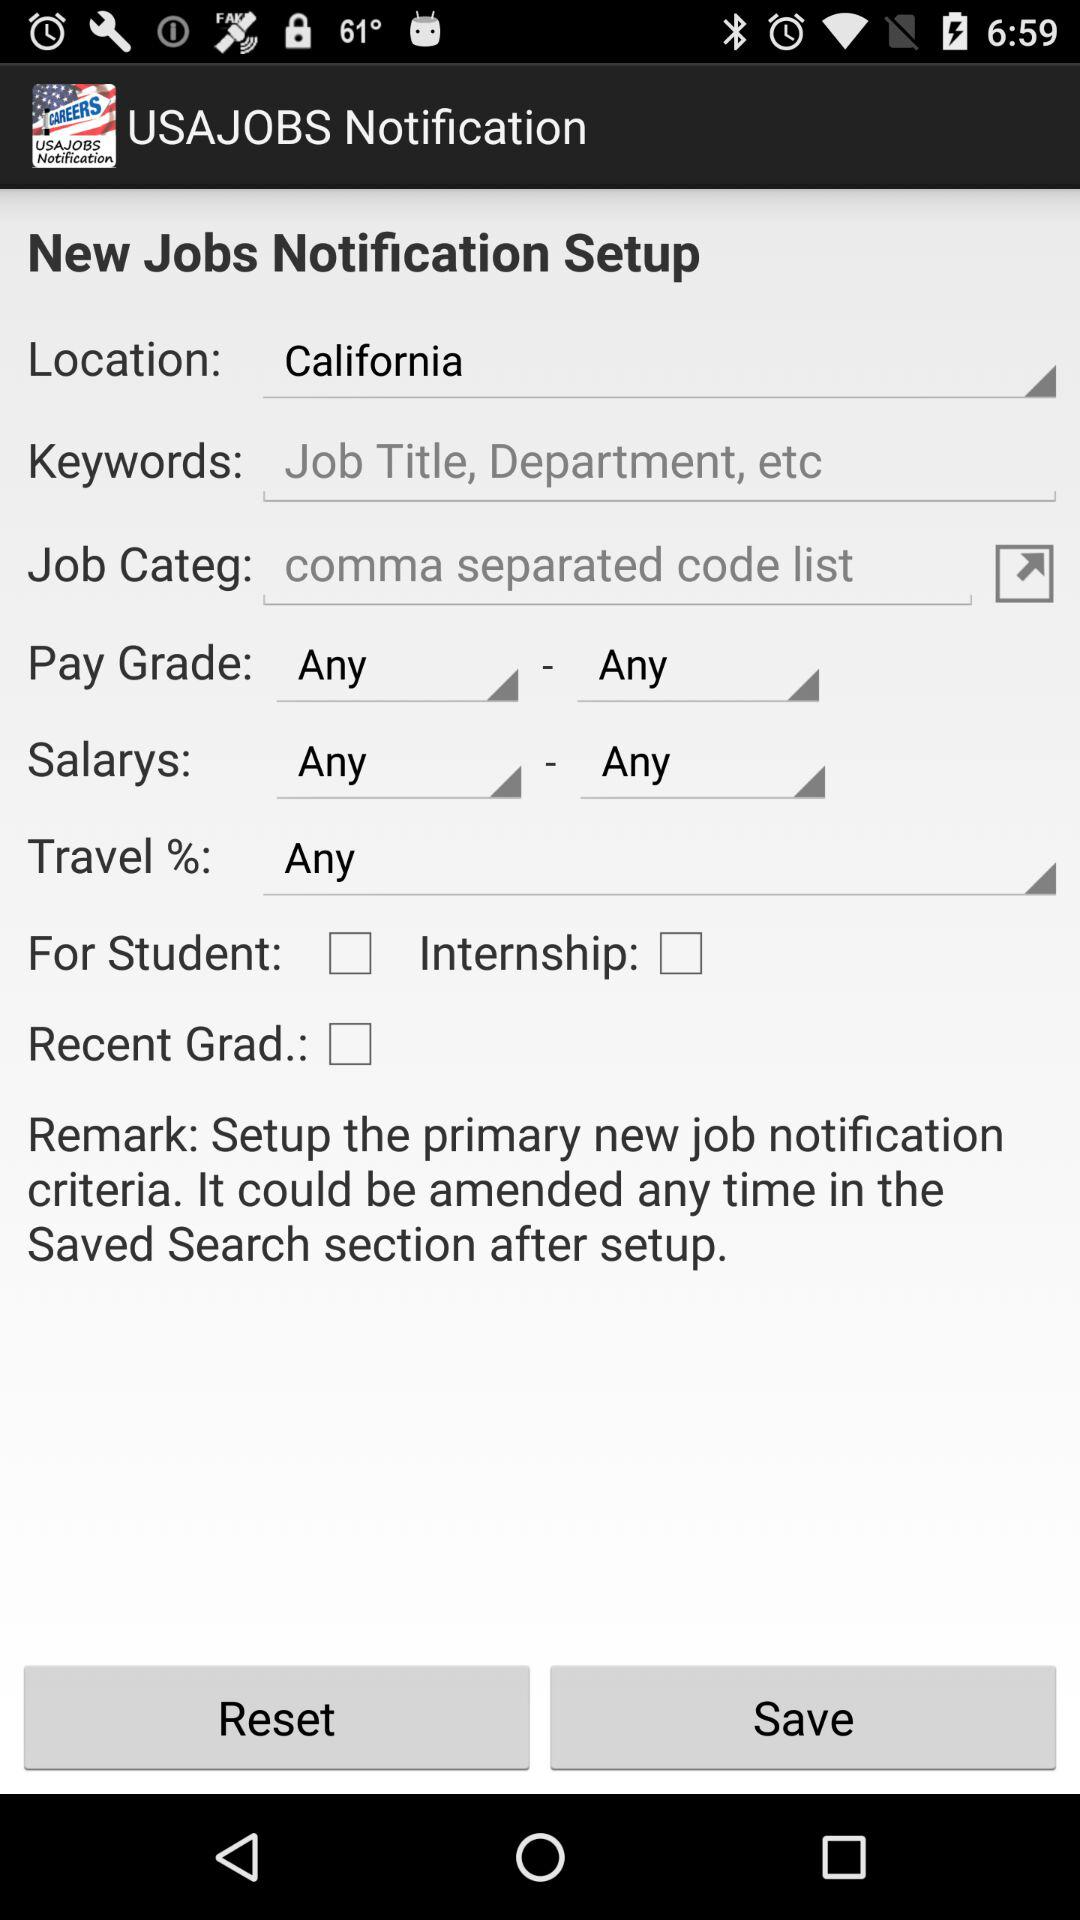What is the location? The location is California. 